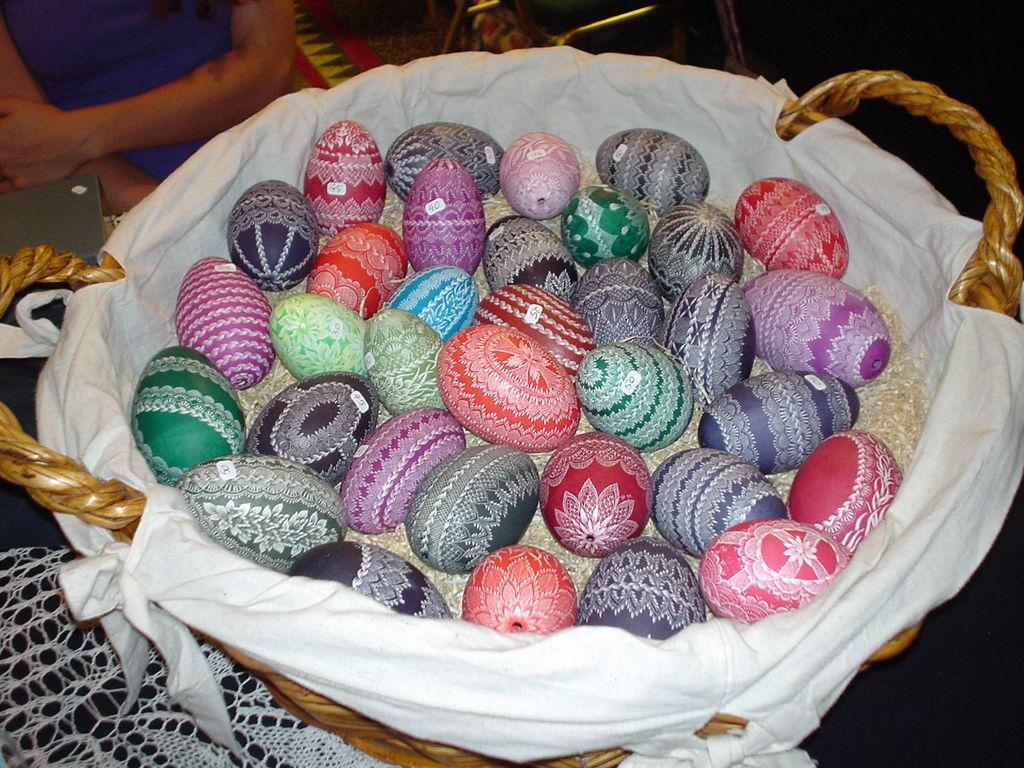What objects are present in the picture? There are eggs in the picture. How are the eggs decorated? The eggs are painted with different colors and have different designs. What colors can be seen on the eggs in the basket? There are green, violet, blue, and red color eggs in the basket. What type of brass instrument is being played in the image? There is no brass instrument present in the image; it features painted eggs in a basket. 